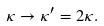Convert formula to latex. <formula><loc_0><loc_0><loc_500><loc_500>\kappa \rightarrow \kappa ^ { \prime } = 2 \kappa .</formula> 